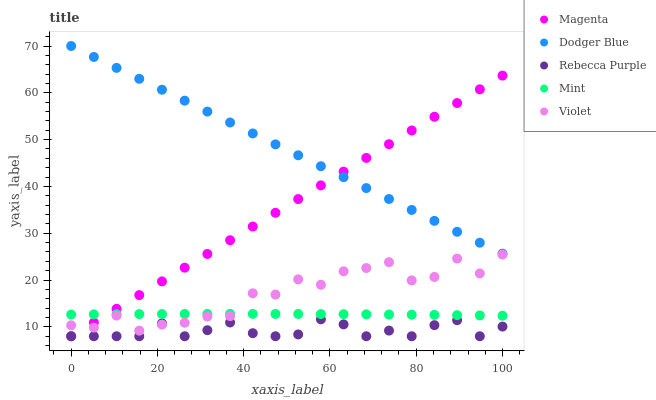Does Rebecca Purple have the minimum area under the curve?
Answer yes or no. Yes. Does Dodger Blue have the maximum area under the curve?
Answer yes or no. Yes. Does Magenta have the minimum area under the curve?
Answer yes or no. No. Does Magenta have the maximum area under the curve?
Answer yes or no. No. Is Dodger Blue the smoothest?
Answer yes or no. Yes. Is Violet the roughest?
Answer yes or no. Yes. Is Magenta the smoothest?
Answer yes or no. No. Is Magenta the roughest?
Answer yes or no. No. Does Magenta have the lowest value?
Answer yes or no. Yes. Does Dodger Blue have the lowest value?
Answer yes or no. No. Does Dodger Blue have the highest value?
Answer yes or no. Yes. Does Magenta have the highest value?
Answer yes or no. No. Is Rebecca Purple less than Dodger Blue?
Answer yes or no. Yes. Is Dodger Blue greater than Violet?
Answer yes or no. Yes. Does Rebecca Purple intersect Magenta?
Answer yes or no. Yes. Is Rebecca Purple less than Magenta?
Answer yes or no. No. Is Rebecca Purple greater than Magenta?
Answer yes or no. No. Does Rebecca Purple intersect Dodger Blue?
Answer yes or no. No. 